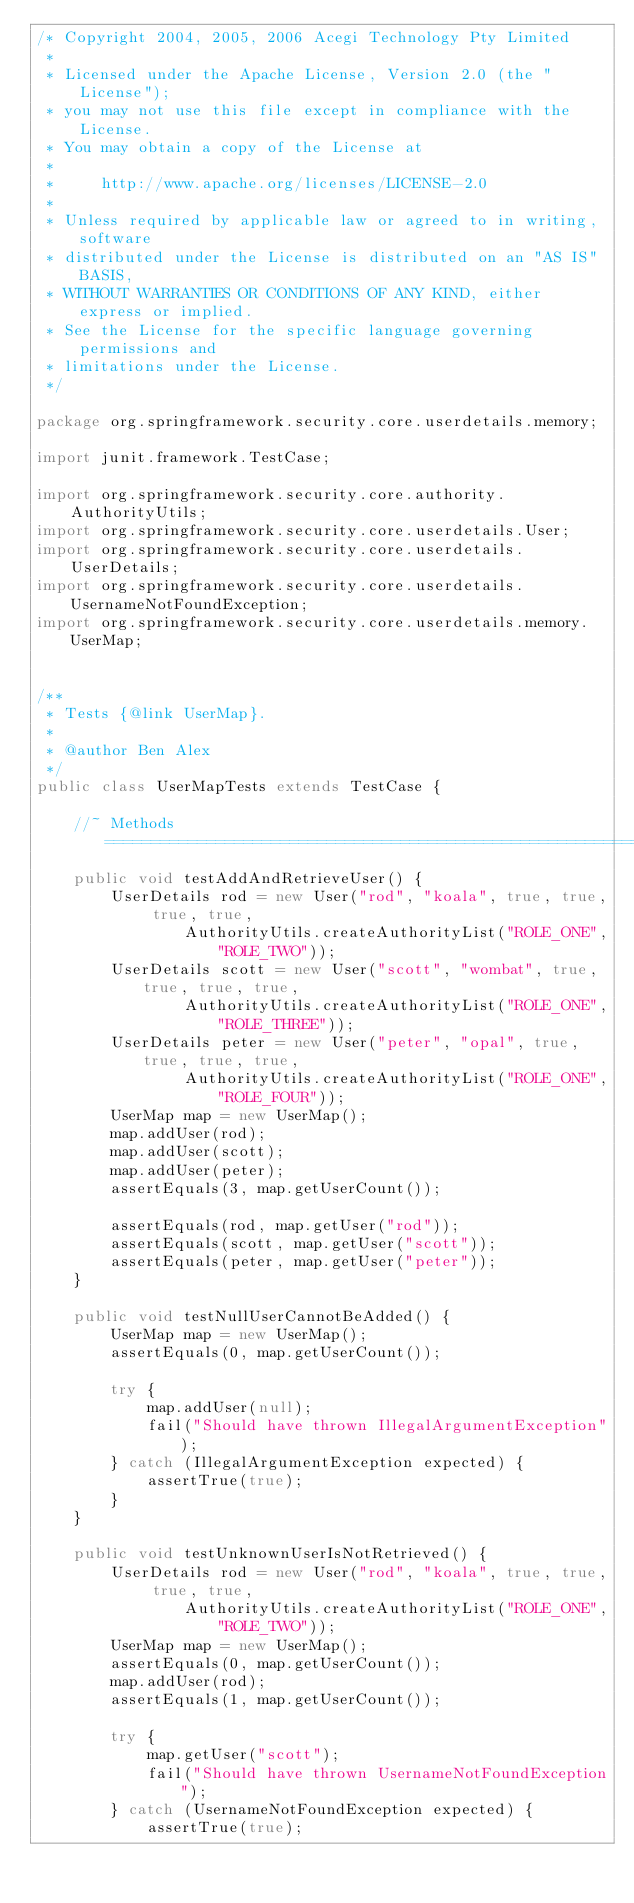<code> <loc_0><loc_0><loc_500><loc_500><_Java_>/* Copyright 2004, 2005, 2006 Acegi Technology Pty Limited
 *
 * Licensed under the Apache License, Version 2.0 (the "License");
 * you may not use this file except in compliance with the License.
 * You may obtain a copy of the License at
 *
 *     http://www.apache.org/licenses/LICENSE-2.0
 *
 * Unless required by applicable law or agreed to in writing, software
 * distributed under the License is distributed on an "AS IS" BASIS,
 * WITHOUT WARRANTIES OR CONDITIONS OF ANY KIND, either express or implied.
 * See the License for the specific language governing permissions and
 * limitations under the License.
 */

package org.springframework.security.core.userdetails.memory;

import junit.framework.TestCase;

import org.springframework.security.core.authority.AuthorityUtils;
import org.springframework.security.core.userdetails.User;
import org.springframework.security.core.userdetails.UserDetails;
import org.springframework.security.core.userdetails.UsernameNotFoundException;
import org.springframework.security.core.userdetails.memory.UserMap;


/**
 * Tests {@link UserMap}.
 *
 * @author Ben Alex
 */
public class UserMapTests extends TestCase {

    //~ Methods ========================================================================================================
    public void testAddAndRetrieveUser() {
        UserDetails rod = new User("rod", "koala", true, true, true, true,
                AuthorityUtils.createAuthorityList("ROLE_ONE","ROLE_TWO"));
        UserDetails scott = new User("scott", "wombat", true, true, true, true,
                AuthorityUtils.createAuthorityList("ROLE_ONE","ROLE_THREE"));
        UserDetails peter = new User("peter", "opal", true, true, true, true,
                AuthorityUtils.createAuthorityList("ROLE_ONE","ROLE_FOUR"));
        UserMap map = new UserMap();
        map.addUser(rod);
        map.addUser(scott);
        map.addUser(peter);
        assertEquals(3, map.getUserCount());

        assertEquals(rod, map.getUser("rod"));
        assertEquals(scott, map.getUser("scott"));
        assertEquals(peter, map.getUser("peter"));
    }

    public void testNullUserCannotBeAdded() {
        UserMap map = new UserMap();
        assertEquals(0, map.getUserCount());

        try {
            map.addUser(null);
            fail("Should have thrown IllegalArgumentException");
        } catch (IllegalArgumentException expected) {
            assertTrue(true);
        }
    }

    public void testUnknownUserIsNotRetrieved() {
        UserDetails rod = new User("rod", "koala", true, true, true, true,
                AuthorityUtils.createAuthorityList("ROLE_ONE","ROLE_TWO"));
        UserMap map = new UserMap();
        assertEquals(0, map.getUserCount());
        map.addUser(rod);
        assertEquals(1, map.getUserCount());

        try {
            map.getUser("scott");
            fail("Should have thrown UsernameNotFoundException");
        } catch (UsernameNotFoundException expected) {
            assertTrue(true);</code> 